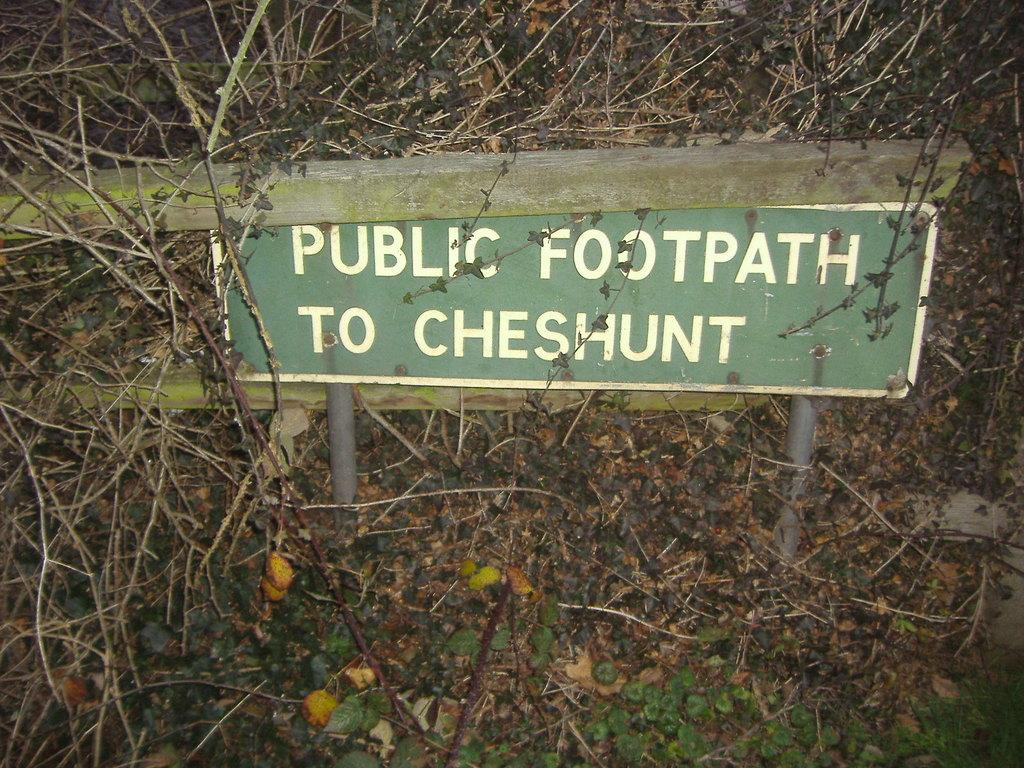What is the main object in the center of the image? There is a board in the center of the image. What is written or depicted on the board? There is text on the board. What type of natural environment is visible in the image? Trees and grass are visible in the image. Can you see a bee buzzing around the board in the image? There is no bee visible in the image. What color is the stomach of the person holding the board in the image? There is no person holding the board in the image, so it is not possible to determine the color of their stomach. 